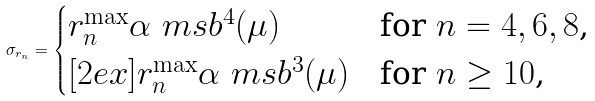Convert formula to latex. <formula><loc_0><loc_0><loc_500><loc_500>\sigma _ { r _ { n } } = \begin{cases} r _ { n } ^ { \max } \alpha _ { \ } m s b ^ { 4 } ( \mu ) & \text {for $n=4,6,8$,} \\ [ 2 e x ] r _ { n } ^ { \max } \alpha _ { \ } m s b ^ { 3 } ( \mu ) & \text {for $n\geq10$,} \end{cases}</formula> 